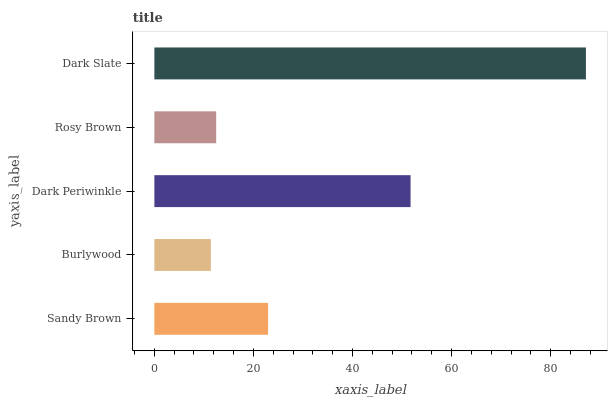Is Burlywood the minimum?
Answer yes or no. Yes. Is Dark Slate the maximum?
Answer yes or no. Yes. Is Dark Periwinkle the minimum?
Answer yes or no. No. Is Dark Periwinkle the maximum?
Answer yes or no. No. Is Dark Periwinkle greater than Burlywood?
Answer yes or no. Yes. Is Burlywood less than Dark Periwinkle?
Answer yes or no. Yes. Is Burlywood greater than Dark Periwinkle?
Answer yes or no. No. Is Dark Periwinkle less than Burlywood?
Answer yes or no. No. Is Sandy Brown the high median?
Answer yes or no. Yes. Is Sandy Brown the low median?
Answer yes or no. Yes. Is Dark Periwinkle the high median?
Answer yes or no. No. Is Rosy Brown the low median?
Answer yes or no. No. 